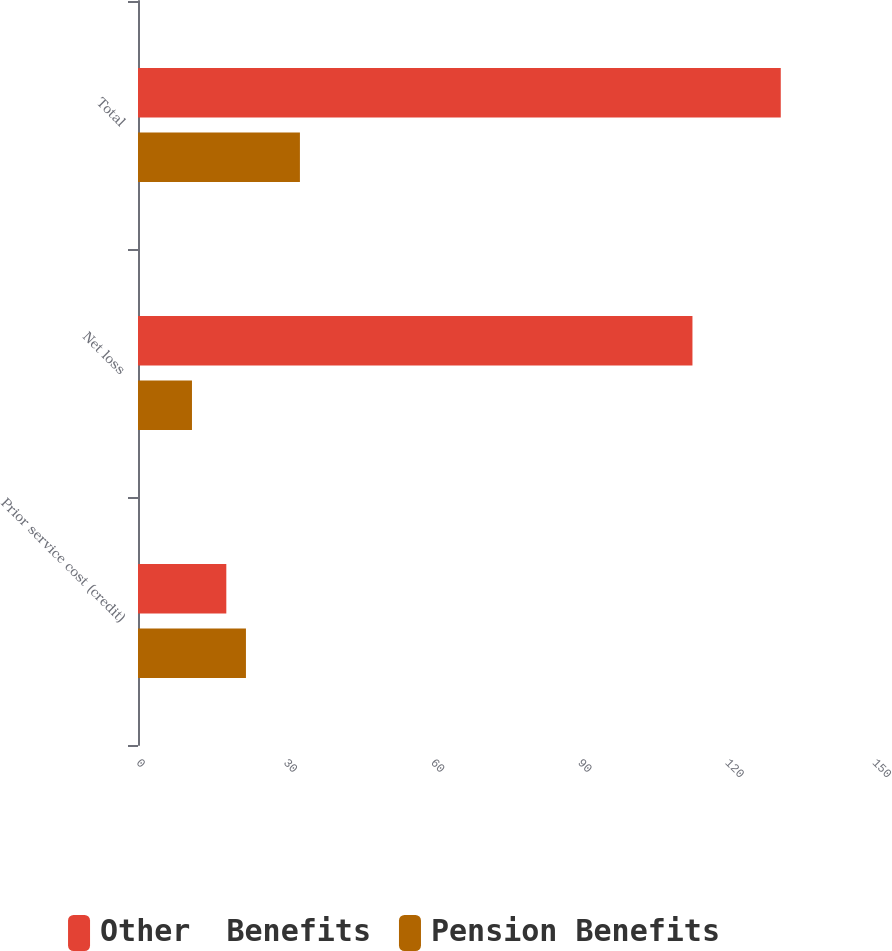Convert chart. <chart><loc_0><loc_0><loc_500><loc_500><stacked_bar_chart><ecel><fcel>Prior service cost (credit)<fcel>Net loss<fcel>Total<nl><fcel>Other  Benefits<fcel>18<fcel>113<fcel>131<nl><fcel>Pension Benefits<fcel>22<fcel>11<fcel>33<nl></chart> 